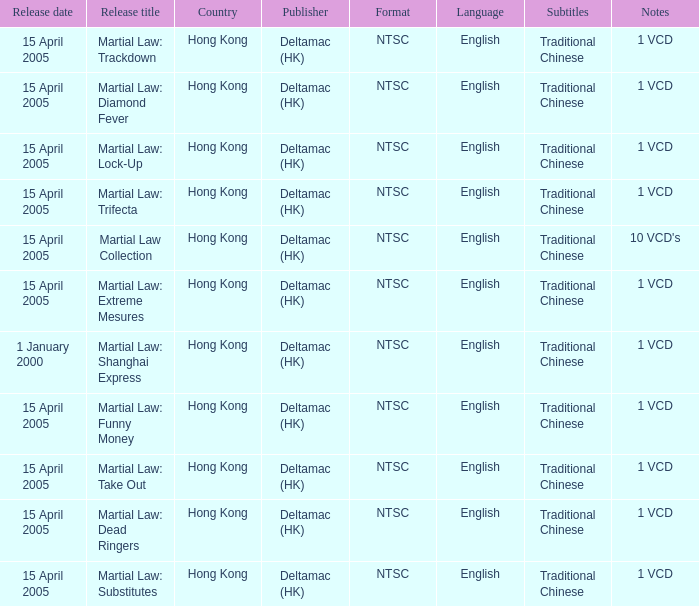Which publisher released Martial Law: Substitutes? Deltamac (HK). 